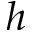<formula> <loc_0><loc_0><loc_500><loc_500>h</formula> 